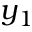Convert formula to latex. <formula><loc_0><loc_0><loc_500><loc_500>y _ { 1 }</formula> 